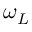<formula> <loc_0><loc_0><loc_500><loc_500>\omega _ { L }</formula> 